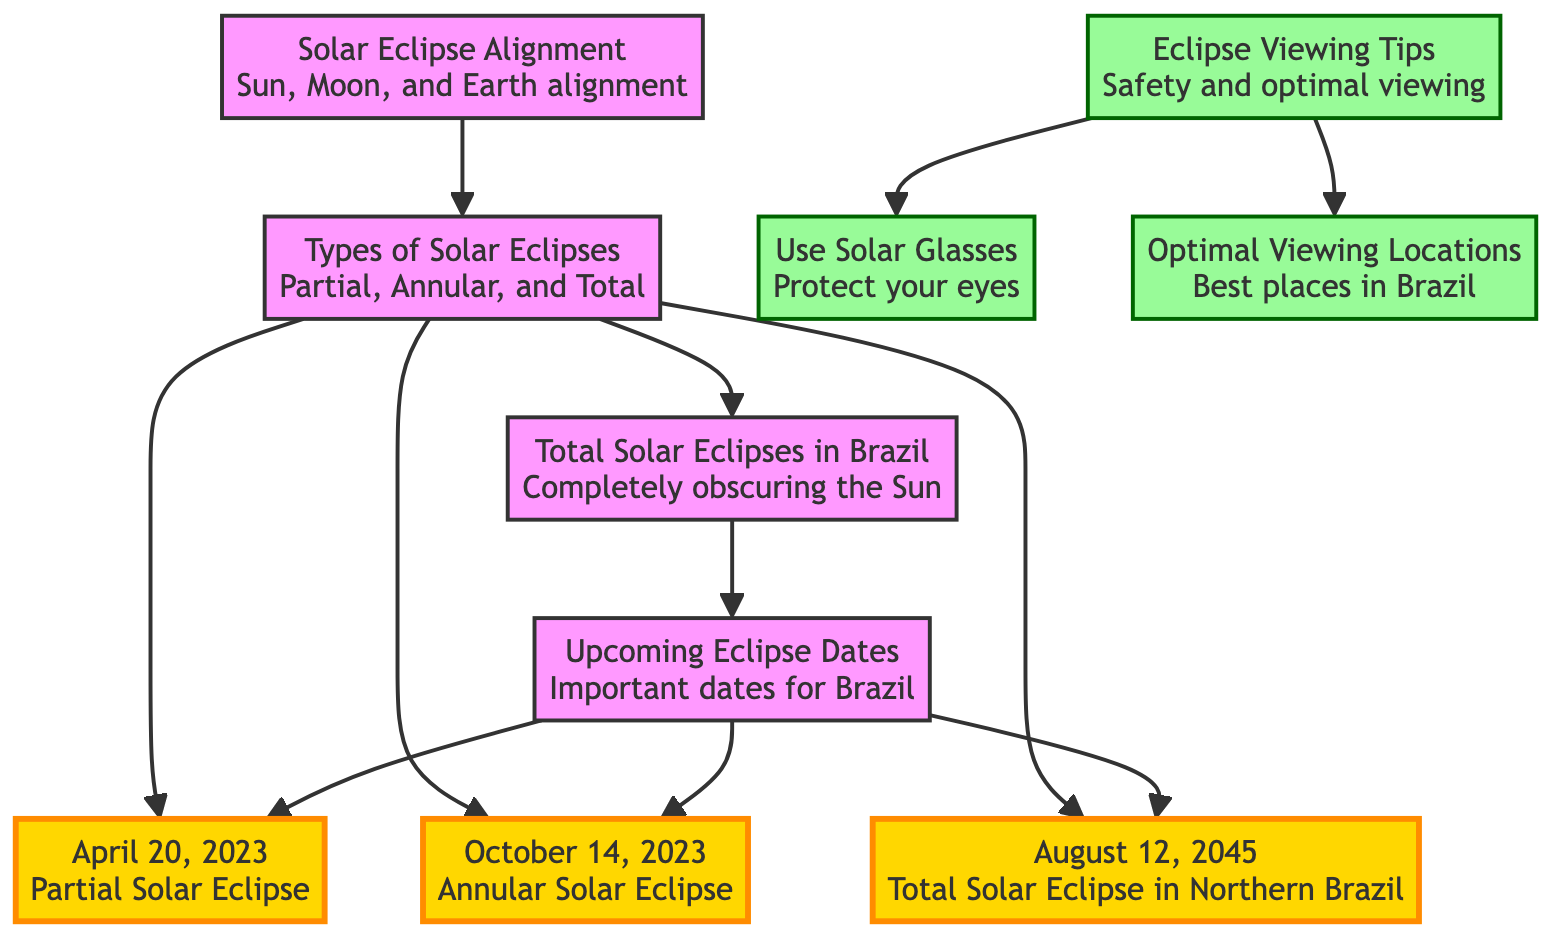What are the types of solar eclipses mentioned? The diagram lists three types of solar eclipses: Partial, Annular, and Total. These are displayed under the node labeled "Types of Solar Eclipses."
Answer: Partial, Annular, Total How many total solar eclipses are mentioned for Brazil? The diagram highlights one total solar eclipse that will be visible in Brazil, occurring on August 12, 2045, which is identified under the "Total Solar Eclipses in Brazil" node.
Answer: 1 When is the next upcoming solar eclipse in Brazil? According to the "Upcoming Eclipse Dates" node, the next solar eclipse mentioned is on October 14, 2023, which is an annular solar eclipse.
Answer: October 14, 2023 What safety tip is provided for viewing eclipses? The "Eclipse Viewing Tips" node states that it is important to "Use Solar Glasses" to protect your eyes while viewing a solar eclipse.
Answer: Use Solar Glasses What is the total number of upcoming eclipses listed in the diagram? Under the "Upcoming Eclipse Dates" node, there are three solar eclipses listed: April 20, 2023; October 14, 2023; and August 12, 2045. Therefore, counting these, the total is three.
Answer: 3 What is the eclipse type for the event on April 20, 2023? The node for "April 20, 2023" indicates that this date corresponds to a Partial Solar Eclipse, which answers the question about the type of solar eclipse on that date.
Answer: Partial Solar Eclipse In which part of Brazil will the total solar eclipse on August 12, 2045, be visible? The diagram specifies that the total solar eclipse on August 12, 2045, will be visible in Northern Brazil, providing geographical context for the event.
Answer: Northern Brazil What are optimal viewing locations for eclipses? The "Eclipse Viewing Tips" node includes a mention of "Optimal Viewing Locations," indicating that there are suggested best places in Brazil for viewing solar eclipses.
Answer: Optimal Viewing Locations 